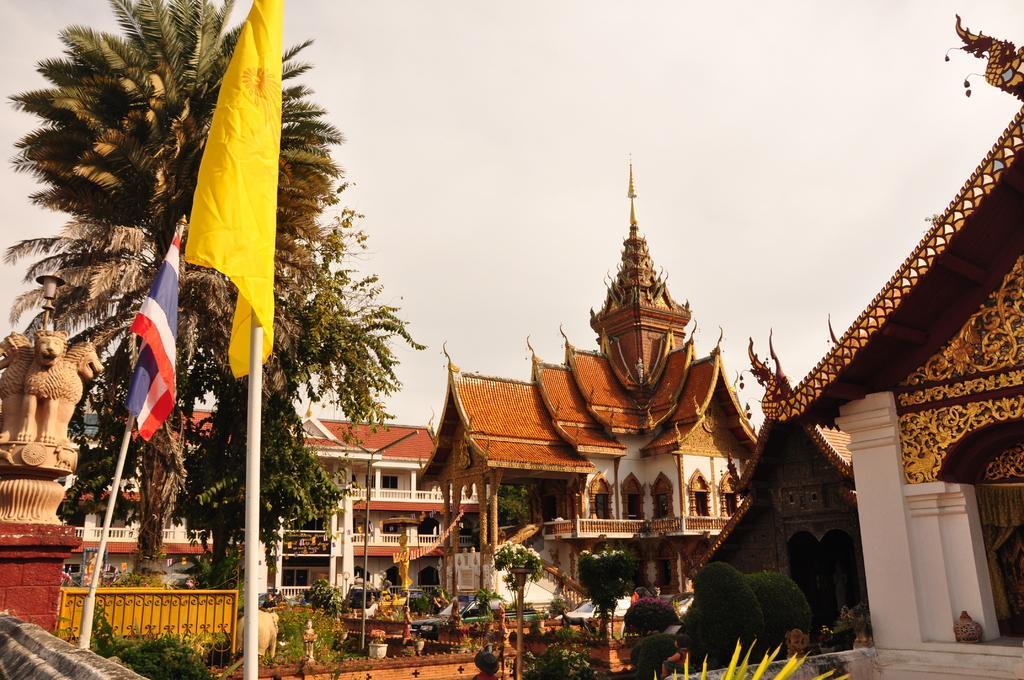Could you give a brief overview of what you see in this image? In this picture we can see some buildings here, on the left side there are two flags, there are some trees and plants here, we can see the sky at the top of the picture, we can see a pillar here. 